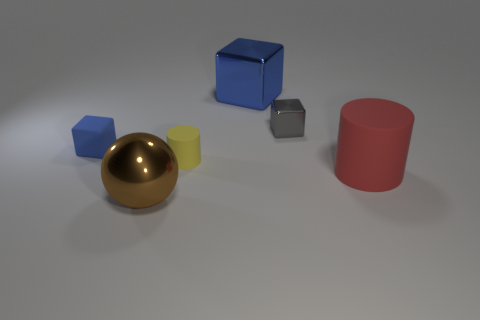Subtract all brown cubes. Subtract all blue cylinders. How many cubes are left? 3 Add 3 large brown things. How many objects exist? 9 Subtract all cylinders. How many objects are left? 4 Subtract 0 brown cylinders. How many objects are left? 6 Subtract all tiny cubes. Subtract all large metal cubes. How many objects are left? 3 Add 1 red rubber cylinders. How many red rubber cylinders are left? 2 Add 6 big green metal objects. How many big green metal objects exist? 6 